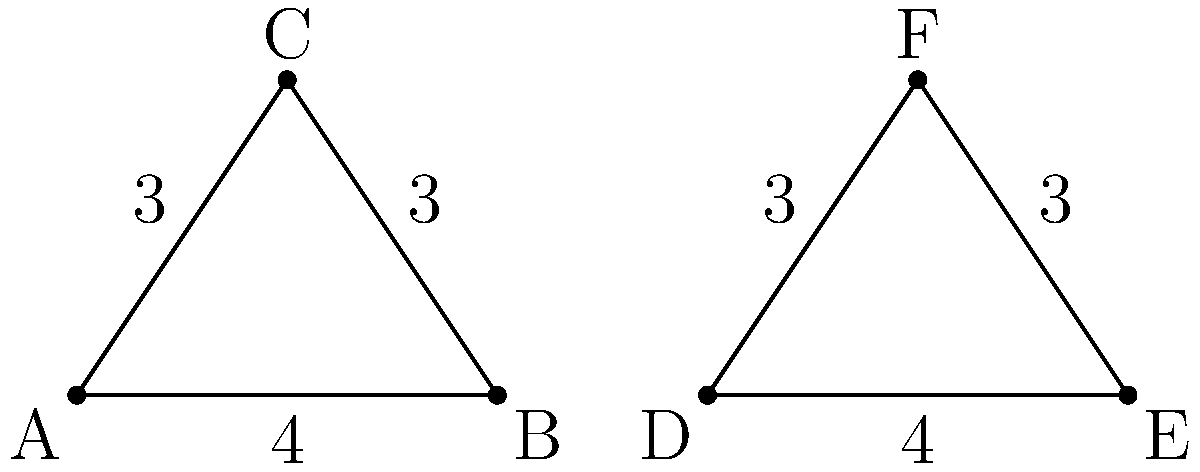As you prepare to reopen your dojo, you're considering purchasing new triangular floor mats for training exercises. You have two options: Mat 1 (triangle ABC) and Mat 2 (triangle DEF). Both mats have side lengths of 4 units, 3 units, and 3 units. Are these two triangular floor mats congruent? If so, state which congruence criterion applies. To determine if the two triangular floor mats are congruent, we need to compare their corresponding sides and angles. Let's approach this step-by-step:

1. Compare the side lengths:
   - Mat 1 (ABC): AB = 4, AC = BC = 3
   - Mat 2 (DEF): DE = 4, DF = EF = 3

   We can see that all corresponding sides are equal.

2. Recall the Side-Side-Side (SSS) Congruence Criterion:
   If three sides of one triangle are equal to the corresponding three sides of another triangle, then the triangles are congruent.

3. Apply the SSS Criterion:
   - AB = DE (both 4 units)
   - AC = DF (both 3 units)
   - BC = EF (both 3 units)

   All three pairs of corresponding sides are equal.

4. Conclusion:
   Since all three pairs of corresponding sides are equal, the SSS Congruence Criterion is satisfied. Therefore, triangle ABC (Mat 1) is congruent to triangle DEF (Mat 2).

This means that the two floor mats will have exactly the same shape and size, which is important for maintaining consistency in your training area.
Answer: Yes, congruent by SSS Criterion. 